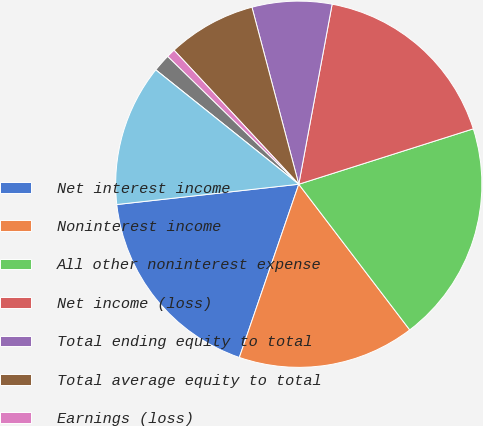Convert chart to OTSL. <chart><loc_0><loc_0><loc_500><loc_500><pie_chart><fcel>Net interest income<fcel>Noninterest income<fcel>All other noninterest expense<fcel>Net income (loss)<fcel>Total ending equity to total<fcel>Total average equity to total<fcel>Earnings (loss)<fcel>Diluted earnings (loss) (2)<fcel>Dividends paid<fcel>Book value<nl><fcel>17.97%<fcel>15.62%<fcel>19.53%<fcel>17.19%<fcel>7.03%<fcel>7.81%<fcel>0.78%<fcel>1.56%<fcel>0.0%<fcel>12.5%<nl></chart> 